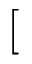Convert formula to latex. <formula><loc_0><loc_0><loc_500><loc_500>[</formula> 